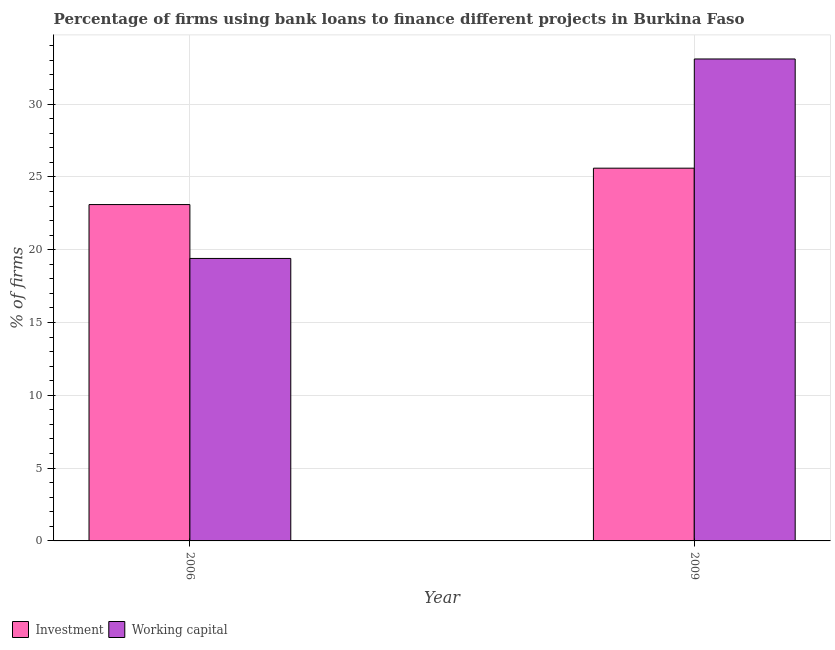Are the number of bars on each tick of the X-axis equal?
Ensure brevity in your answer.  Yes. How many bars are there on the 2nd tick from the right?
Give a very brief answer. 2. What is the label of the 2nd group of bars from the left?
Your answer should be compact. 2009. In how many cases, is the number of bars for a given year not equal to the number of legend labels?
Your answer should be compact. 0. What is the percentage of firms using banks to finance investment in 2006?
Keep it short and to the point. 23.1. Across all years, what is the maximum percentage of firms using banks to finance investment?
Keep it short and to the point. 25.6. Across all years, what is the minimum percentage of firms using banks to finance investment?
Provide a succinct answer. 23.1. In which year was the percentage of firms using banks to finance working capital maximum?
Provide a succinct answer. 2009. In which year was the percentage of firms using banks to finance investment minimum?
Offer a terse response. 2006. What is the total percentage of firms using banks to finance working capital in the graph?
Offer a very short reply. 52.5. What is the difference between the percentage of firms using banks to finance investment in 2009 and the percentage of firms using banks to finance working capital in 2006?
Offer a very short reply. 2.5. What is the average percentage of firms using banks to finance working capital per year?
Offer a terse response. 26.25. In the year 2006, what is the difference between the percentage of firms using banks to finance investment and percentage of firms using banks to finance working capital?
Provide a short and direct response. 0. In how many years, is the percentage of firms using banks to finance investment greater than 4 %?
Offer a very short reply. 2. What is the ratio of the percentage of firms using banks to finance investment in 2006 to that in 2009?
Offer a very short reply. 0.9. What does the 2nd bar from the left in 2009 represents?
Ensure brevity in your answer.  Working capital. What does the 2nd bar from the right in 2006 represents?
Keep it short and to the point. Investment. How many bars are there?
Give a very brief answer. 4. Are all the bars in the graph horizontal?
Provide a succinct answer. No. How many years are there in the graph?
Keep it short and to the point. 2. What is the title of the graph?
Give a very brief answer. Percentage of firms using bank loans to finance different projects in Burkina Faso. What is the label or title of the X-axis?
Offer a very short reply. Year. What is the label or title of the Y-axis?
Your response must be concise. % of firms. What is the % of firms in Investment in 2006?
Your answer should be compact. 23.1. What is the % of firms in Investment in 2009?
Offer a very short reply. 25.6. What is the % of firms in Working capital in 2009?
Give a very brief answer. 33.1. Across all years, what is the maximum % of firms of Investment?
Keep it short and to the point. 25.6. Across all years, what is the maximum % of firms in Working capital?
Provide a short and direct response. 33.1. Across all years, what is the minimum % of firms in Investment?
Ensure brevity in your answer.  23.1. Across all years, what is the minimum % of firms in Working capital?
Keep it short and to the point. 19.4. What is the total % of firms of Investment in the graph?
Provide a succinct answer. 48.7. What is the total % of firms in Working capital in the graph?
Make the answer very short. 52.5. What is the difference between the % of firms in Working capital in 2006 and that in 2009?
Offer a very short reply. -13.7. What is the difference between the % of firms of Investment in 2006 and the % of firms of Working capital in 2009?
Your answer should be compact. -10. What is the average % of firms in Investment per year?
Your answer should be compact. 24.35. What is the average % of firms of Working capital per year?
Your answer should be very brief. 26.25. In the year 2006, what is the difference between the % of firms of Investment and % of firms of Working capital?
Offer a very short reply. 3.7. What is the ratio of the % of firms of Investment in 2006 to that in 2009?
Offer a terse response. 0.9. What is the ratio of the % of firms in Working capital in 2006 to that in 2009?
Your answer should be compact. 0.59. What is the difference between the highest and the second highest % of firms in Working capital?
Your response must be concise. 13.7. 